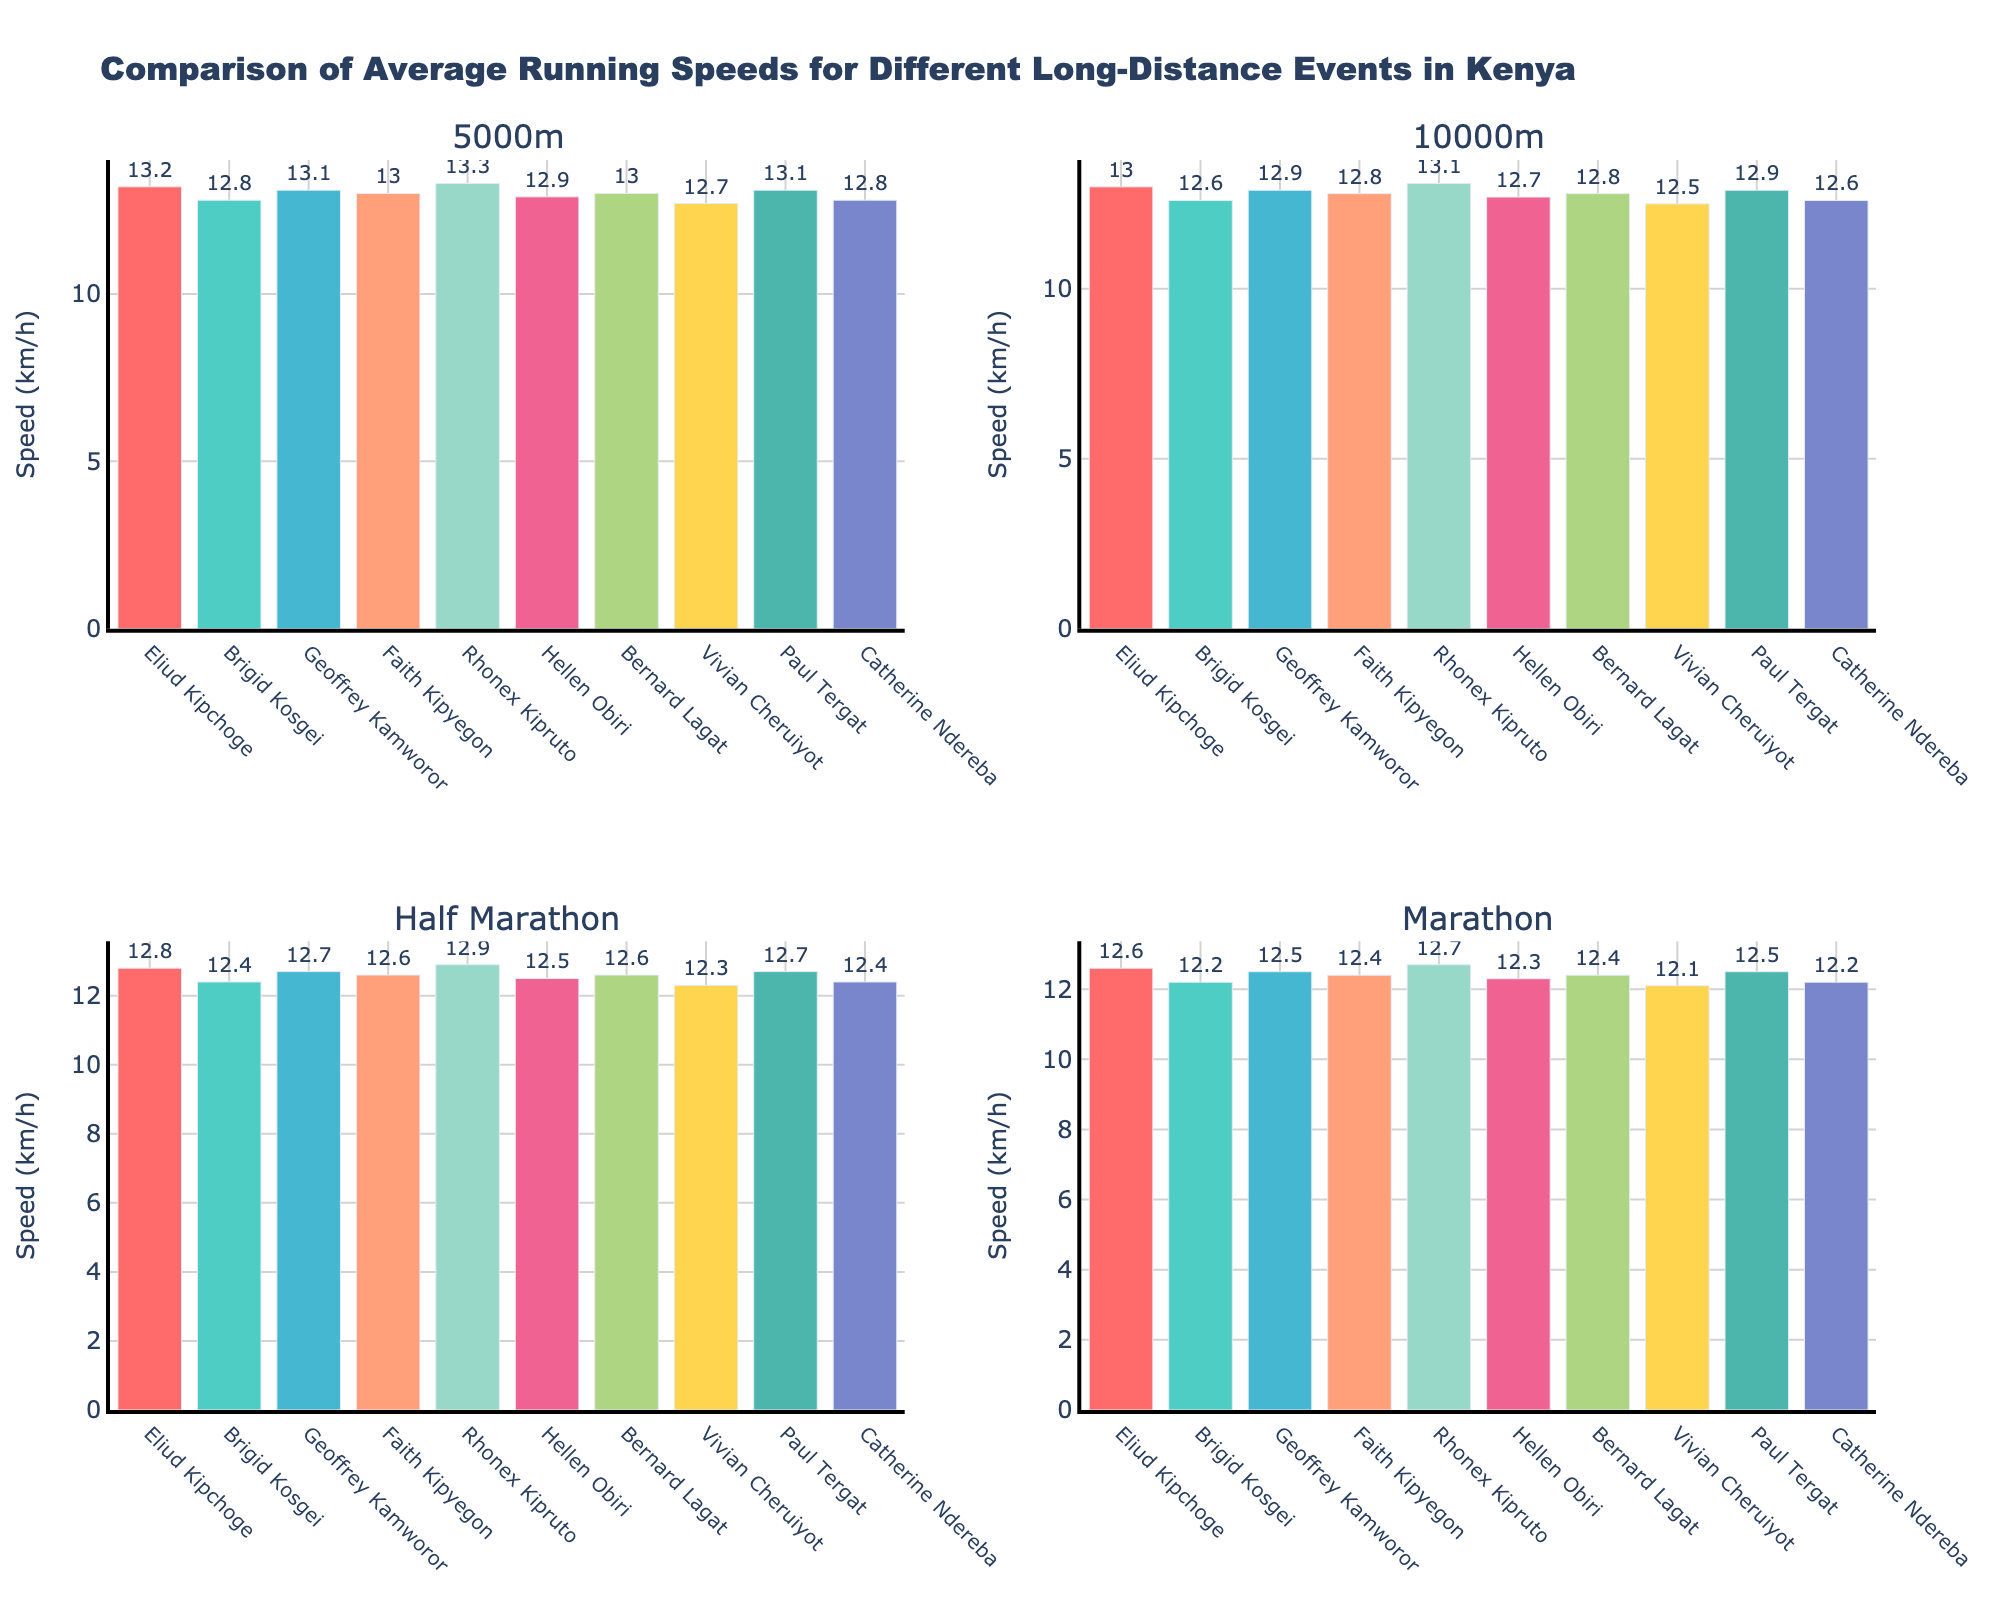What's the title of the figure? The title can be found at the top center of the figure. It reads: "Player Appearances by Position in 1982 Season".
Answer: Player Appearances by Position in 1982 Season How many players are represented in the "Forwards" subplot? The "Forwards" subplot shows the number of bars, each representing a player. There are 3 bars in the “Forwards” subplot.
Answer: 3 Which defender had the most appearances? In the "Defenders" subplot, the bar with the most appearances represents Alex Tobin.
Answer: Alex Tobin What's the total number of appearances by midfielders? Add the appearances of all midfielders: Milan Ivanovic (32), Aurelio Vidmar (29), Ross Aloisi (27), Ernie Tapai (25). 32 + 29 + 27 + 25 = 113.
Answer: 113 Who is the player with the second highest number of appearances among all forwards? In the "Forwards" subplot, Carl Veart has the most appearances (31) and Damian Mori comes next with 28 appearances.
Answer: Damian Mori What is the difference in appearances between the midfielder with the most appearances and the defender with the least? The midfielder with the most appearances is Milan Ivanovic (32), the defender with the least is Angelo Costanzo (24). The difference is 32 - 24 = 8.
Answer: 8 Who had more appearances: the top midfielder or the top forward? The top midfielder (Milan Ivanovic) has 32 appearances, while the top forward (Carl Veart) has 31 appearances. So, the top midfielder had more appearances.
Answer: Top midfielder What's the average number of appearances for defenders? Sum the appearances of all defenders: John Perin (28), Sergio Melta (26), Angelo Costanzo (24), Alex Tobin (30). 28 + 26 + 24 + 30 = 108. The average is 108 / 4 = 27.
Answer: 27 Which group (Defenders, Midfielders, Forwards) has the highest average number of appearances? Calculate the average for each group. Forwards: (31+28+23)/3 = 27.33, Defenders: (28+26+24+30)/4 = 27, Midfielders: (32+29+27+25)/4 = 28.25. Midfielders have the highest average.
Answer: Midfielders 